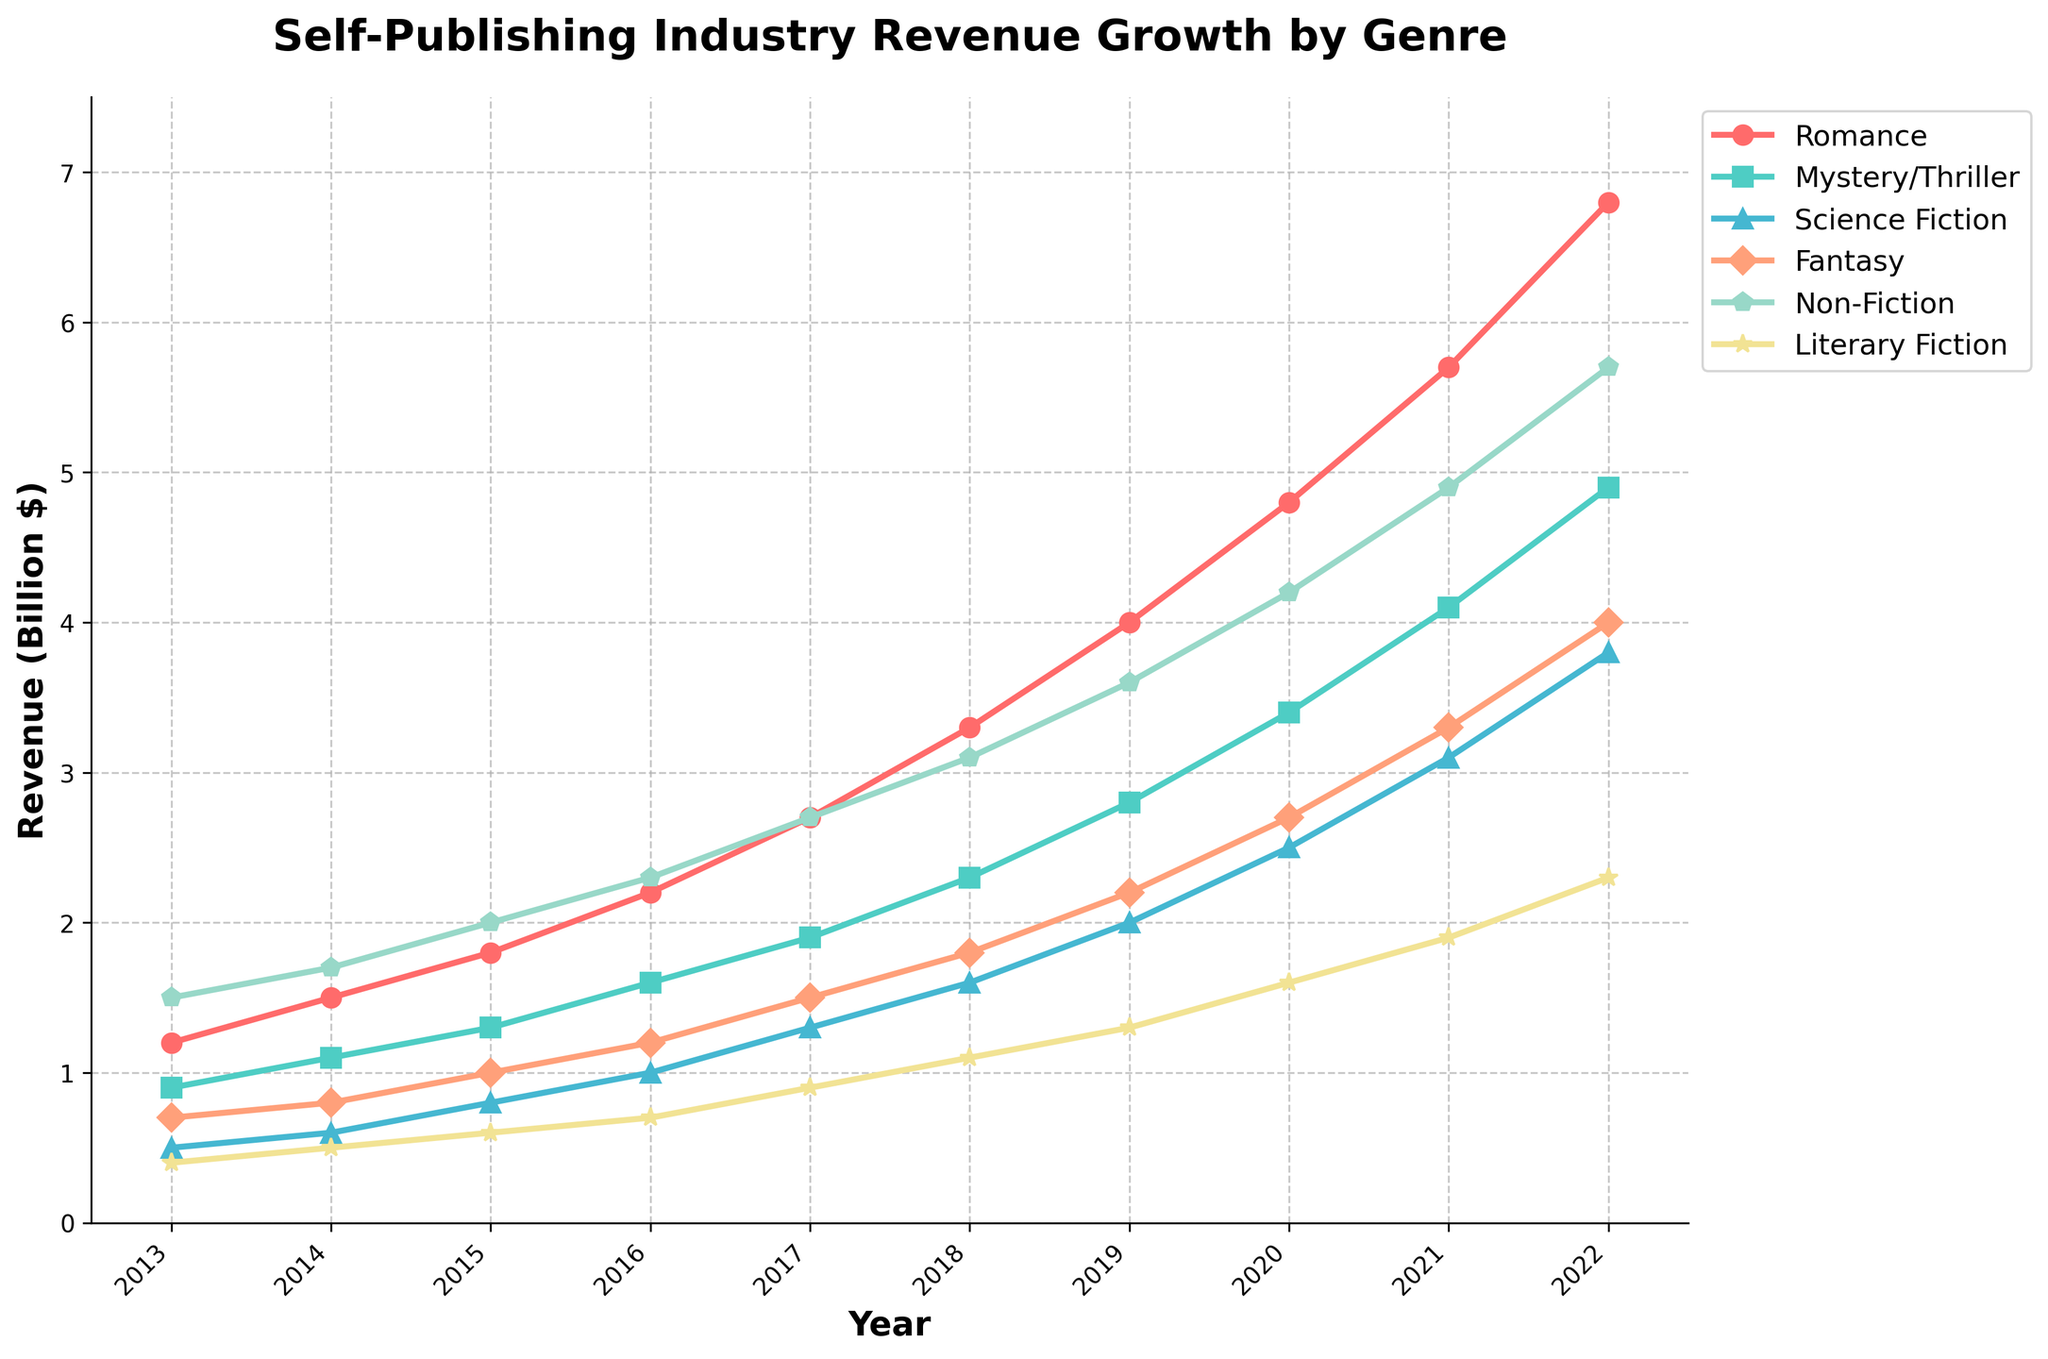What genre experienced the highest revenue growth from 2013 to 2022? To determine this, look at the endpoints of each line on the chart. The Romance genre grows from 1.2 billion in 2013 to 6.8 billion in 2022, which is the largest increase among the genres.
Answer: Romance Between 2015 and 2020, which genre had the greatest average annual revenue? Calculate the average revenue for each genre between 2015 and 2020. Romance had revenues of 1.8, 2.2, 2.7, 3.3, and 4.0, summing to 14.0; the average is 14.0 / 5 = 2.8 billion, which is the greatest among the genres shown.
Answer: Romance In what year did Non-Fiction surpass 3 billion dollars in revenue? Track the Non-Fiction line and see where it crosses the 3-billion-dollar mark on the y-axis. This crossing point occurs between 2017 and 2018.
Answer: 2018 Which two genres showed the most consistent growth over the entire period? Consistent growth is indicated by smoother incremental changes in the lines. Romance and Non-Fiction both exhibit steady upward trends without any abrupt changes.
Answer: Romance and Non-Fiction What was the revenue difference between Mystery/Thriller and Science Fiction in 2022? From the 2022 data, the revenue for Mystery/Thriller is 4.9 billion and for Science Fiction is 3.8 billion. The difference is 4.9 - 3.8 = 1.1 billion.
Answer: 1.1 billion Which genre had the lowest revenue each year across the given period? Observe the lines to see which one remains at the bottom throughout the years. Literary Fiction consistently has the lowest revenue each year.
Answer: Literary Fiction How many genres had their revenue double between 2013 and 2017? Compare revenues from 2013 to 2017 for each genre. Romance (1.2 to 2.7), Mystery/Thriller (0.9 to 1.9), and Non-Fiction (1.5 to 2.7) each doubled.
Answer: 3 genres Which genre had the highest revenue increase between 2019 and 2022? Subtract the 2019 revenue from the 2022 revenue for each genre to find the greatest increase: Romance had an increase from 4.0 to 6.8, which is 6.8 - 4.0 = 2.8 billion.
Answer: Romance Between 2016 and 2022, which genre showed the largest percentage increase in revenue? First, calculate the percentage increase for each genre: Romance (1.0 to 3.1) is about a 300% increase. For each other genre, this percentage is less.
Answer: Science Fiction By how much did Fantasy revenue grow from 2013 to 2022? Subtract the Fantasy revenue in 2013 from that in 2022: 4.0 - 0.7 = 3.3 billion.
Answer: 3.3 billion 